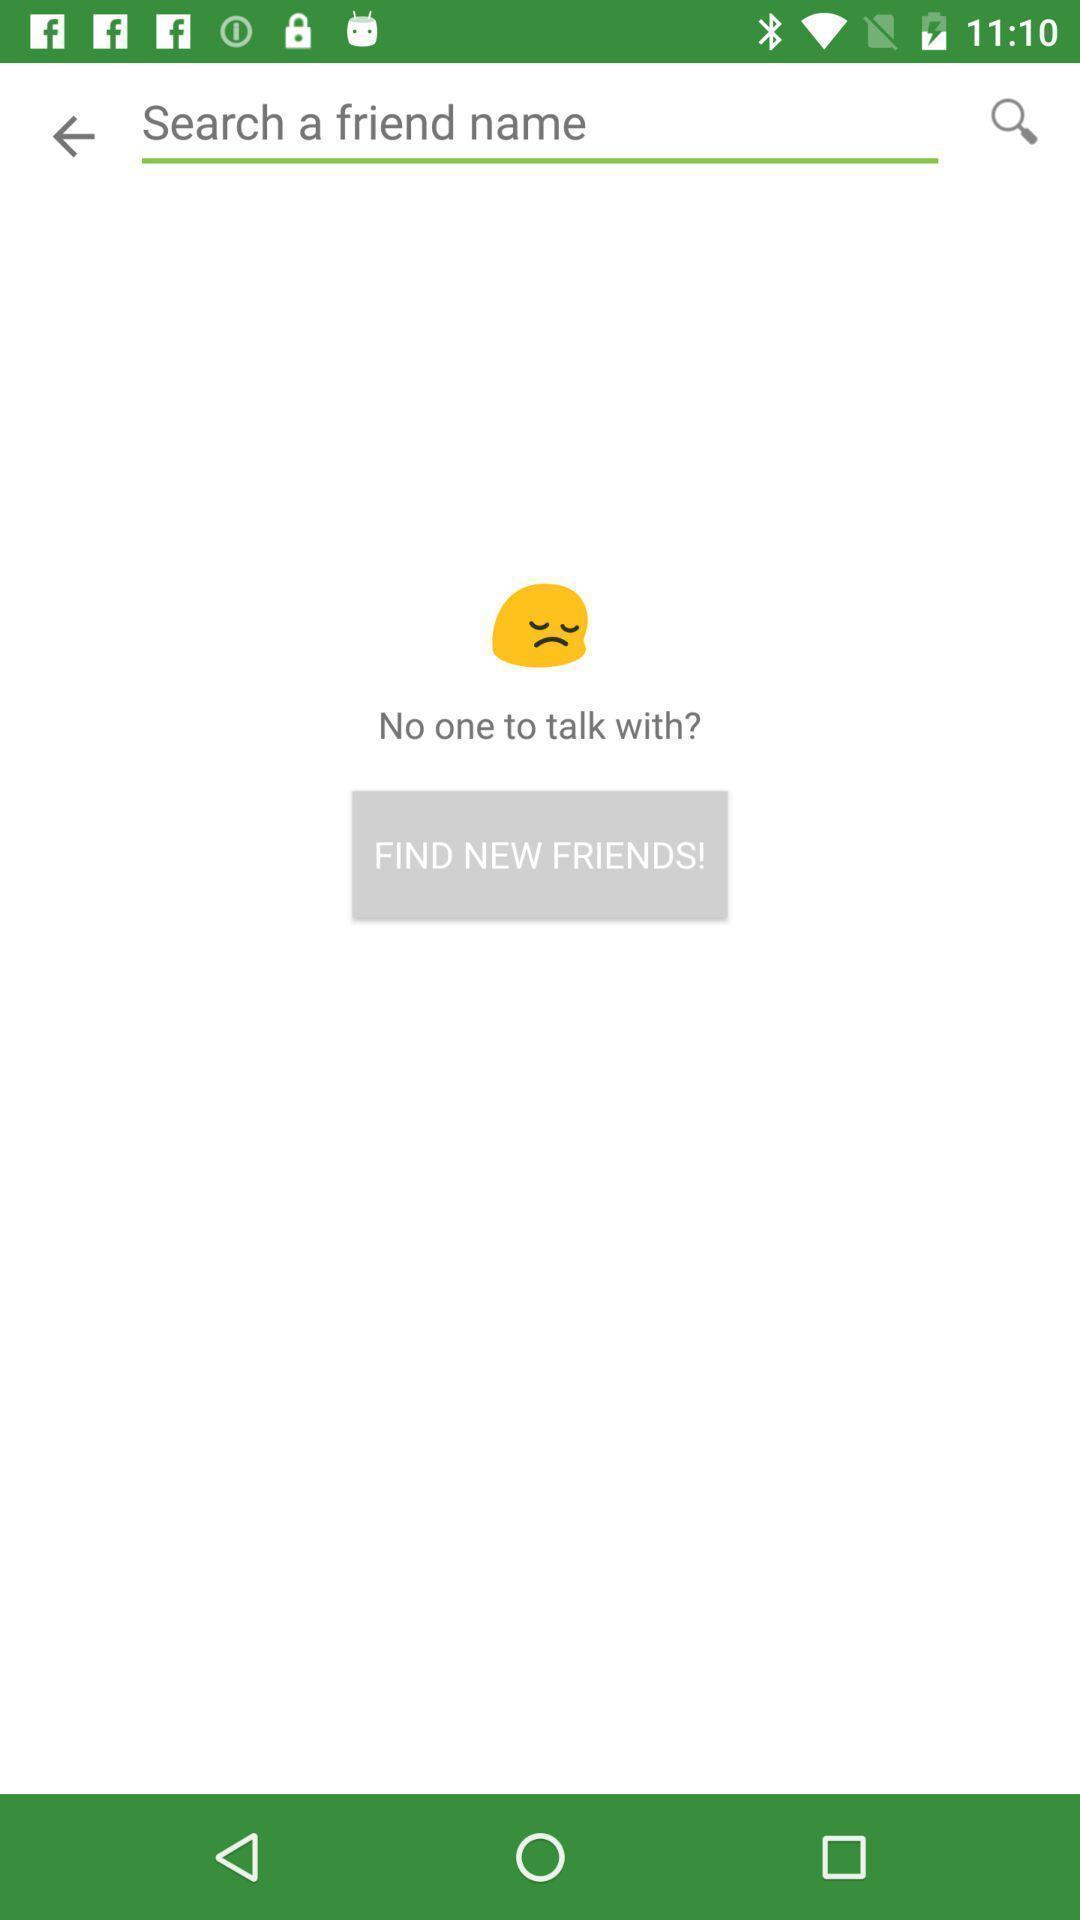Explain what's happening in this screen capture. Screen page displaying an emoji with question. 